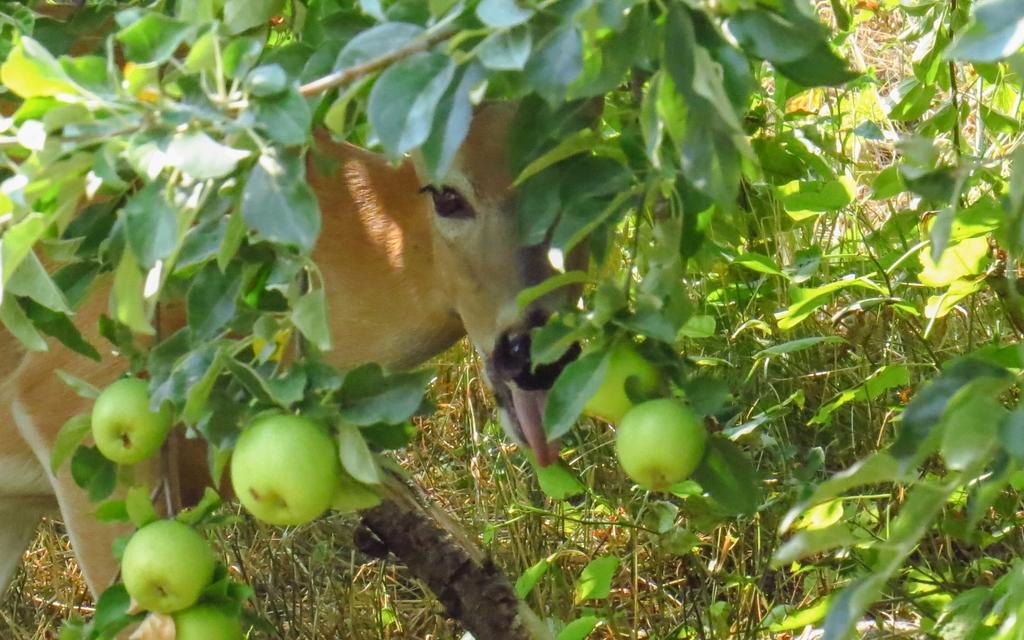What type of animal is present in the image? There is an animal in the image, but its specific type cannot be determined from the provided facts. What can be seen in the tree in the image? There is a tree with fruits in the image. What objects are present on the ground in the image? There are planets on the ground in the image. What type of skin condition does the woman in the image have? There is no woman present in the image, so it is not possible to determine if she has any skin condition. What type of voice does the animal in the image have? The image does not provide any information about the animal's voice, so it cannot be determined. 